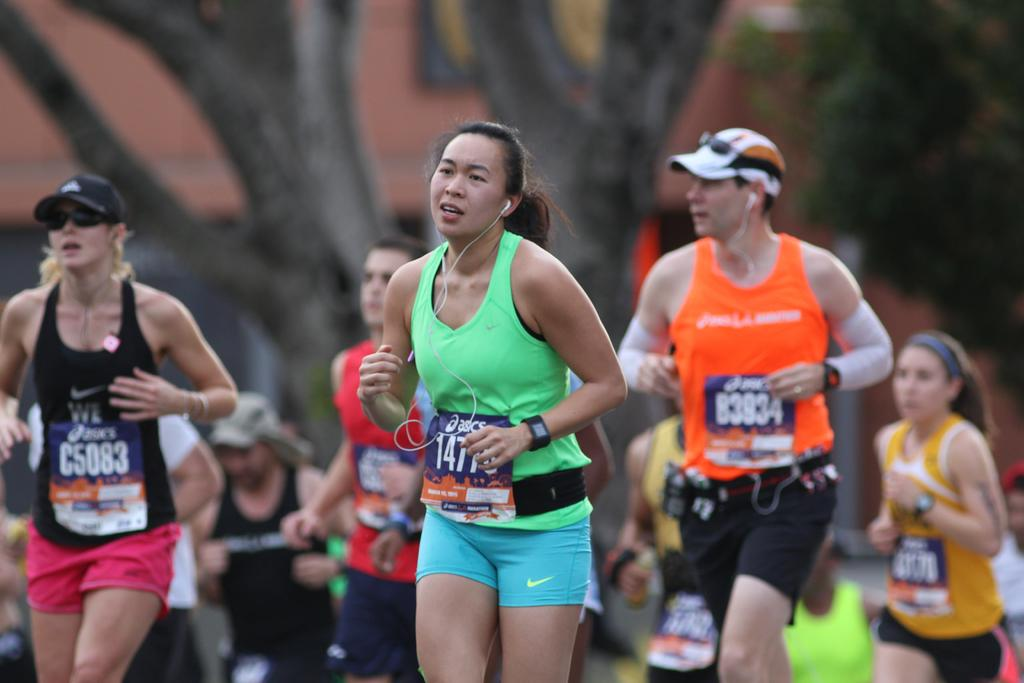Provide a one-sentence caption for the provided image. A group of runners are running a marathon and one has the number C5083 on their shirt. 